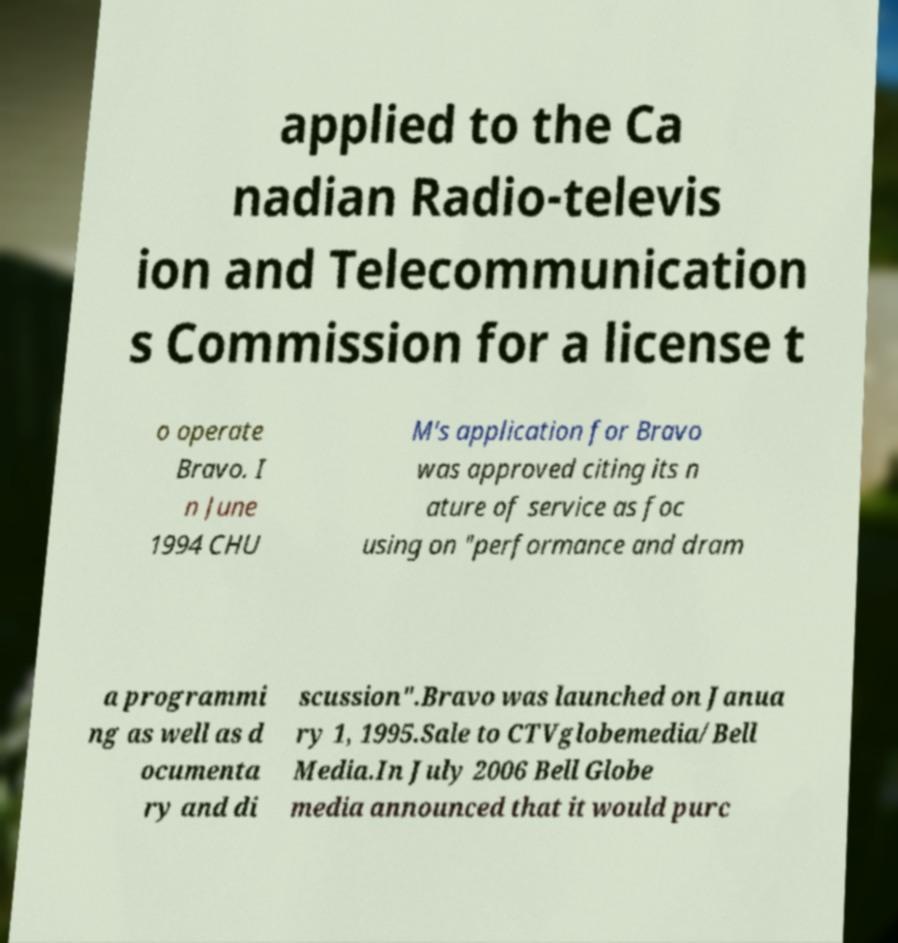Please read and relay the text visible in this image. What does it say? applied to the Ca nadian Radio-televis ion and Telecommunication s Commission for a license t o operate Bravo. I n June 1994 CHU M's application for Bravo was approved citing its n ature of service as foc using on "performance and dram a programmi ng as well as d ocumenta ry and di scussion".Bravo was launched on Janua ry 1, 1995.Sale to CTVglobemedia/Bell Media.In July 2006 Bell Globe media announced that it would purc 